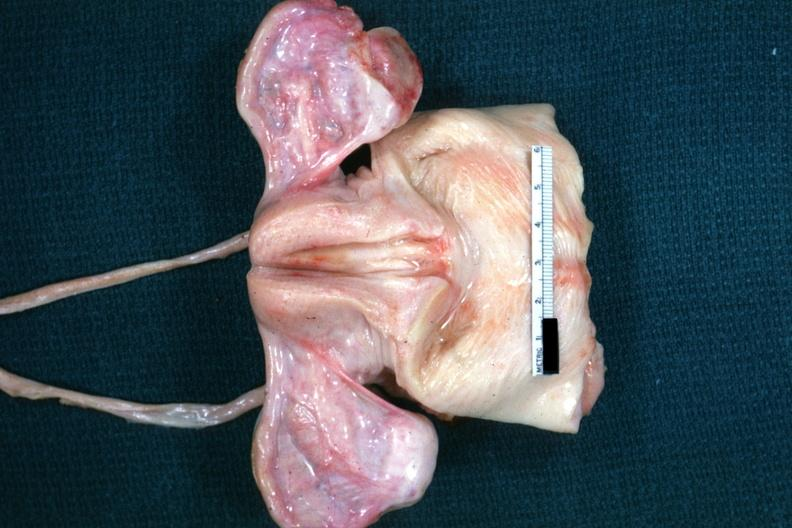s carcinoma present?
Answer the question using a single word or phrase. No 